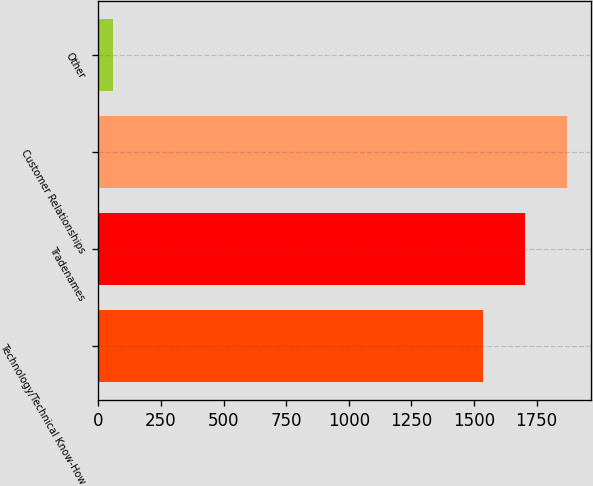Convert chart. <chart><loc_0><loc_0><loc_500><loc_500><bar_chart><fcel>Technology/Technical Know-How<fcel>Tradenames<fcel>Customer Relationships<fcel>Other<nl><fcel>1534<fcel>1702.8<fcel>1871.6<fcel>57<nl></chart> 